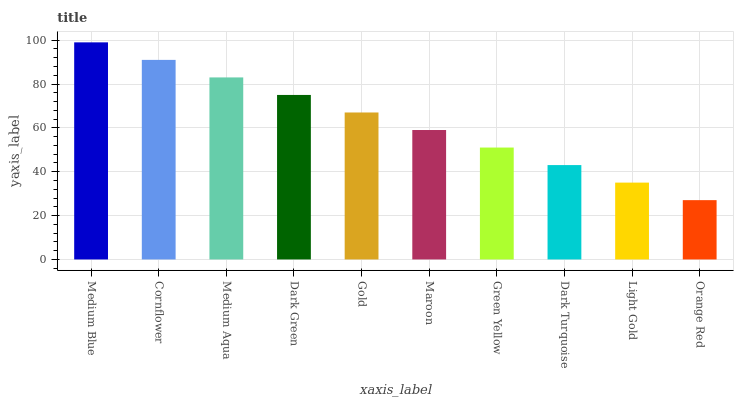Is Orange Red the minimum?
Answer yes or no. Yes. Is Medium Blue the maximum?
Answer yes or no. Yes. Is Cornflower the minimum?
Answer yes or no. No. Is Cornflower the maximum?
Answer yes or no. No. Is Medium Blue greater than Cornflower?
Answer yes or no. Yes. Is Cornflower less than Medium Blue?
Answer yes or no. Yes. Is Cornflower greater than Medium Blue?
Answer yes or no. No. Is Medium Blue less than Cornflower?
Answer yes or no. No. Is Gold the high median?
Answer yes or no. Yes. Is Maroon the low median?
Answer yes or no. Yes. Is Medium Aqua the high median?
Answer yes or no. No. Is Green Yellow the low median?
Answer yes or no. No. 